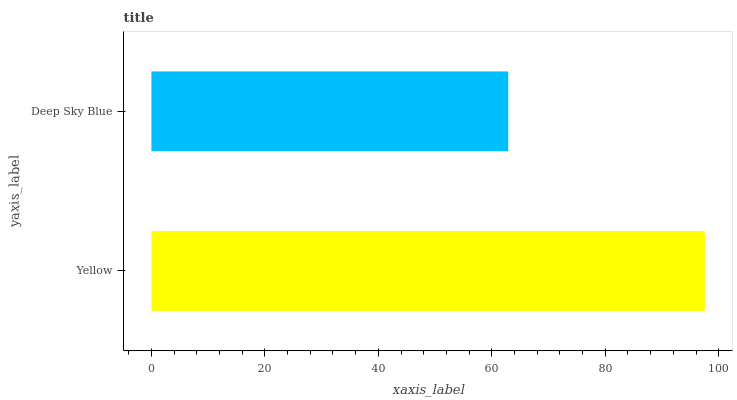Is Deep Sky Blue the minimum?
Answer yes or no. Yes. Is Yellow the maximum?
Answer yes or no. Yes. Is Deep Sky Blue the maximum?
Answer yes or no. No. Is Yellow greater than Deep Sky Blue?
Answer yes or no. Yes. Is Deep Sky Blue less than Yellow?
Answer yes or no. Yes. Is Deep Sky Blue greater than Yellow?
Answer yes or no. No. Is Yellow less than Deep Sky Blue?
Answer yes or no. No. Is Yellow the high median?
Answer yes or no. Yes. Is Deep Sky Blue the low median?
Answer yes or no. Yes. Is Deep Sky Blue the high median?
Answer yes or no. No. Is Yellow the low median?
Answer yes or no. No. 